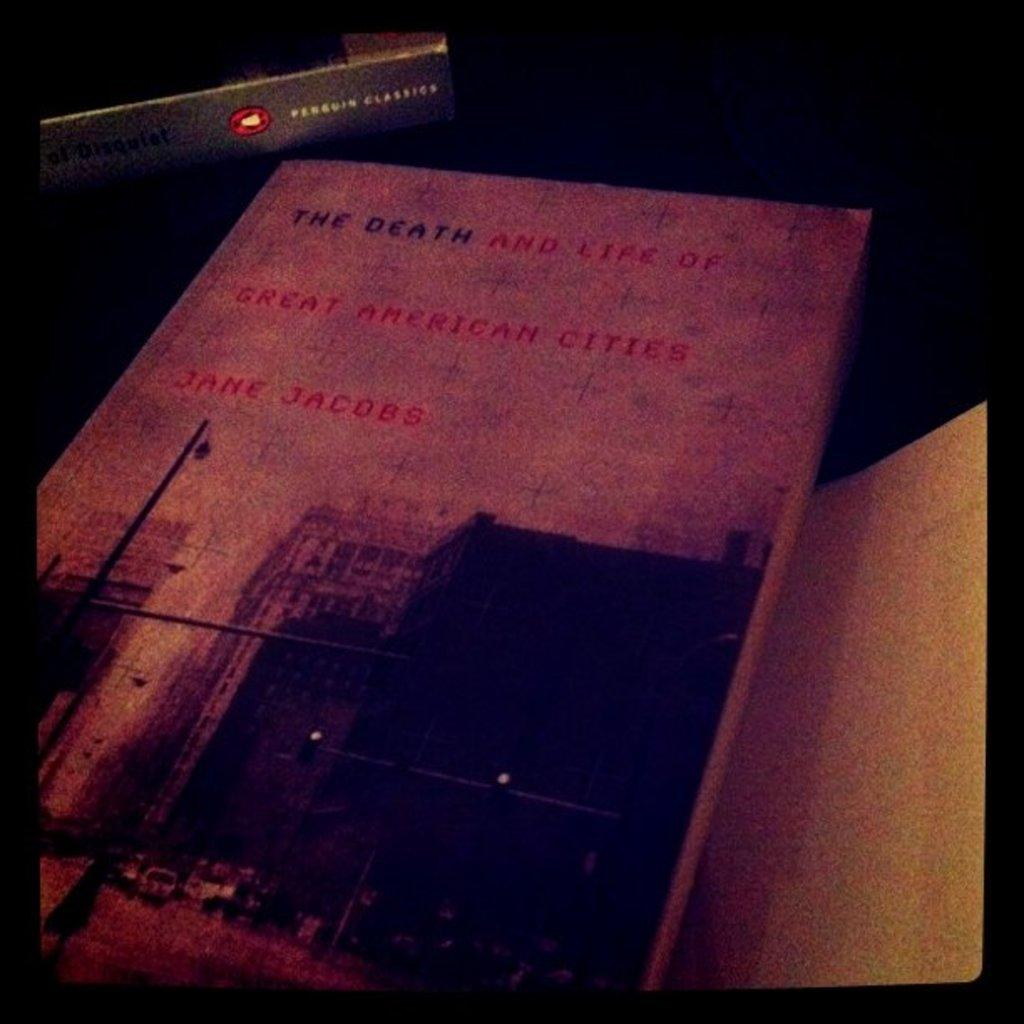<image>
Present a compact description of the photo's key features. old book with picture of city with title the death and life of great american cities 